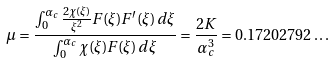<formula> <loc_0><loc_0><loc_500><loc_500>\mu = \frac { \int _ { 0 } ^ { \alpha _ { c } } \frac { 2 \chi ( \xi ) } { \xi ^ { 2 } } F ( \xi ) F ^ { \prime } ( \xi ) \, d \xi } { \int _ { 0 } ^ { \alpha _ { c } } \chi ( \xi ) F ( \xi ) \, d \xi } = \frac { 2 K } { \alpha _ { c } ^ { 3 } } = 0 . 1 7 2 0 2 7 9 2 \dots</formula> 